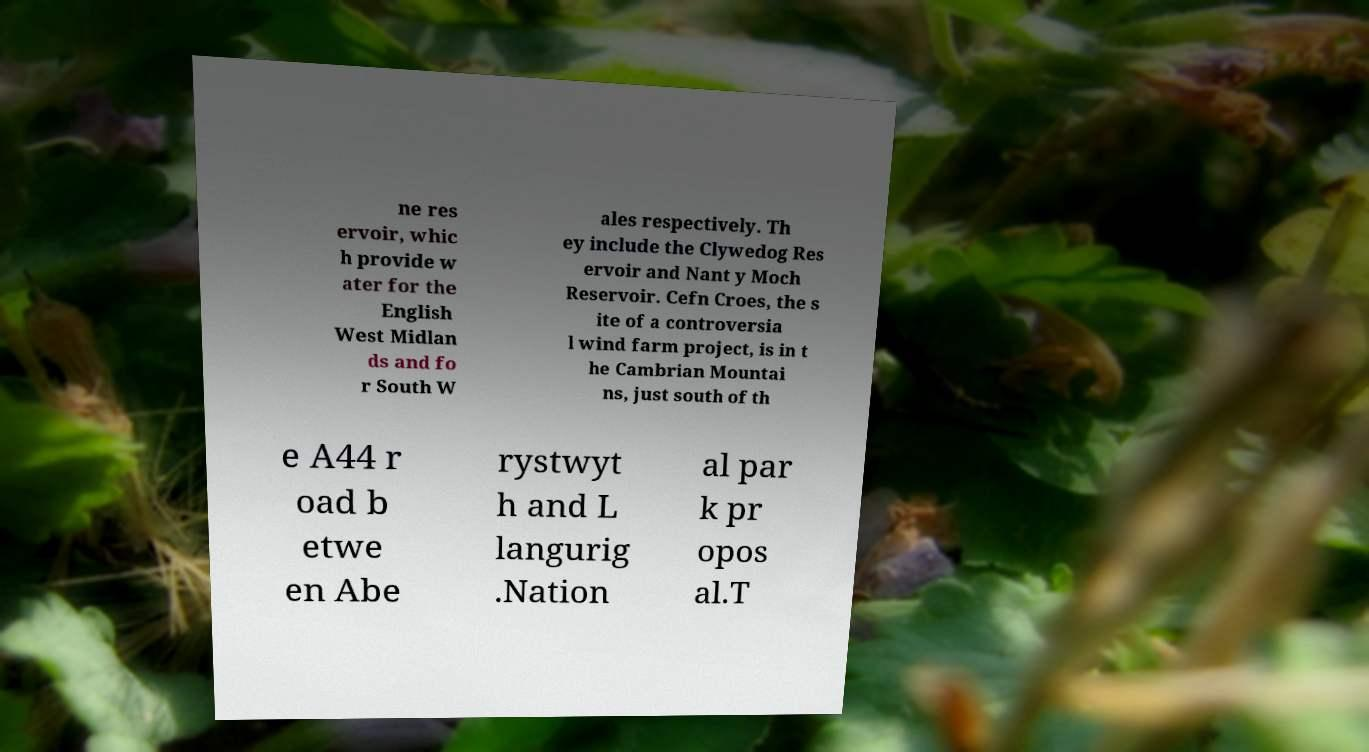Can you read and provide the text displayed in the image?This photo seems to have some interesting text. Can you extract and type it out for me? ne res ervoir, whic h provide w ater for the English West Midlan ds and fo r South W ales respectively. Th ey include the Clywedog Res ervoir and Nant y Moch Reservoir. Cefn Croes, the s ite of a controversia l wind farm project, is in t he Cambrian Mountai ns, just south of th e A44 r oad b etwe en Abe rystwyt h and L langurig .Nation al par k pr opos al.T 